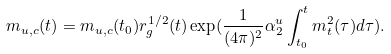Convert formula to latex. <formula><loc_0><loc_0><loc_500><loc_500>m _ { u , c } ( t ) = m _ { u , c } ( t _ { 0 } ) r ^ { 1 / 2 } _ { g } ( t ) \exp ( \frac { 1 } { ( 4 \pi ) ^ { 2 } } \alpha _ { 2 } ^ { u } \int ^ { t } _ { t _ { 0 } } m ^ { 2 } _ { t } ( \tau ) d \tau ) .</formula> 